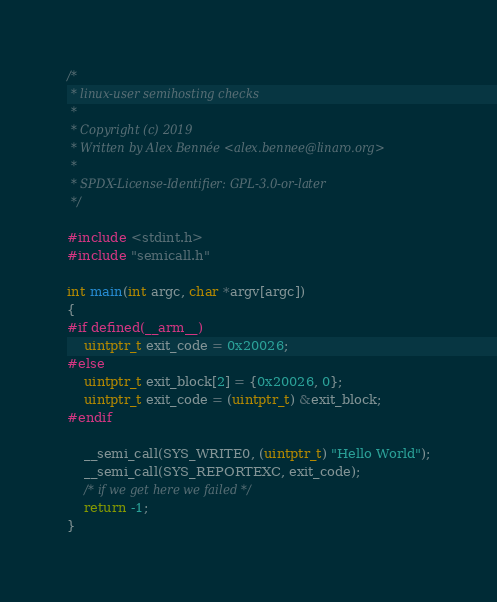<code> <loc_0><loc_0><loc_500><loc_500><_C_>/*
 * linux-user semihosting checks
 *
 * Copyright (c) 2019
 * Written by Alex Bennée <alex.bennee@linaro.org>
 *
 * SPDX-License-Identifier: GPL-3.0-or-later
 */

#include <stdint.h>
#include "semicall.h"

int main(int argc, char *argv[argc])
{
#if defined(__arm__)
    uintptr_t exit_code = 0x20026;
#else
    uintptr_t exit_block[2] = {0x20026, 0};
    uintptr_t exit_code = (uintptr_t) &exit_block;
#endif

    __semi_call(SYS_WRITE0, (uintptr_t) "Hello World");
    __semi_call(SYS_REPORTEXC, exit_code);
    /* if we get here we failed */
    return -1;
}
</code> 